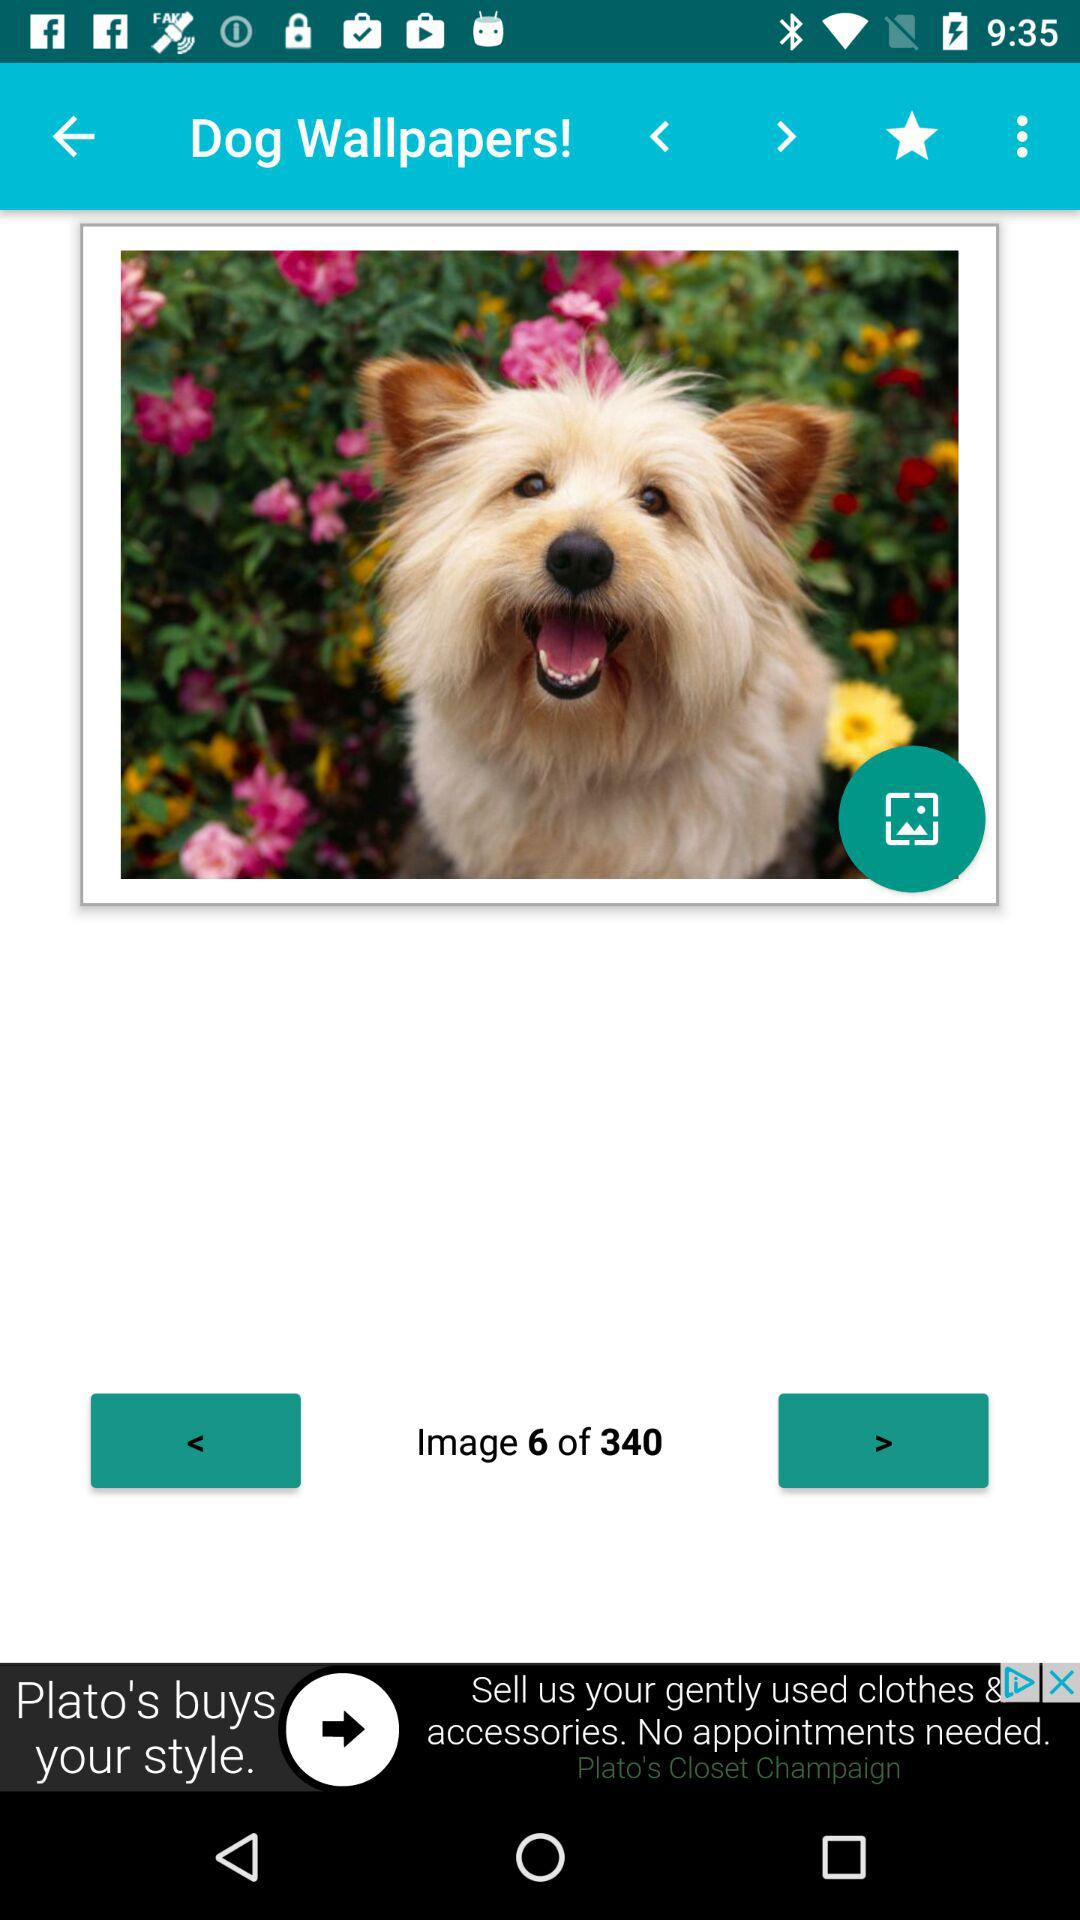How many more arrows are pointing to the left than to the right?
Answer the question using a single word or phrase. 1 